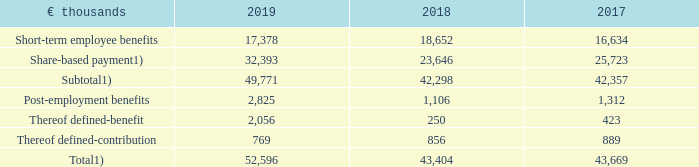The total compensation of the Executive Board members for each of the years 2019, 2018, and 2017 was as follows:
Executive Board Compensation
1) Portion of total executive compensation allocated to the respective year
What was the total amount of Executive Board Compensation in 2019?
Answer scale should be: thousand. 52,596. What does the subtotal amount of compensation relate to? Portion of total executive compensation allocated to the respective year. In which years was the total compensation for Executive Board Members calculated? 2019, 2018, 2017. In which year was the amount Thereof defined-contribution largest? 889>856>769
Answer: 2017. What was the change in Thereof defined-contribution in 2019 from 2018?
Answer scale should be: thousand. 769-856
Answer: -87. What was the percentage change in Thereof defined-contribution in 2019 from 2018?
Answer scale should be: percent. (769-856)/856
Answer: -10.16. 